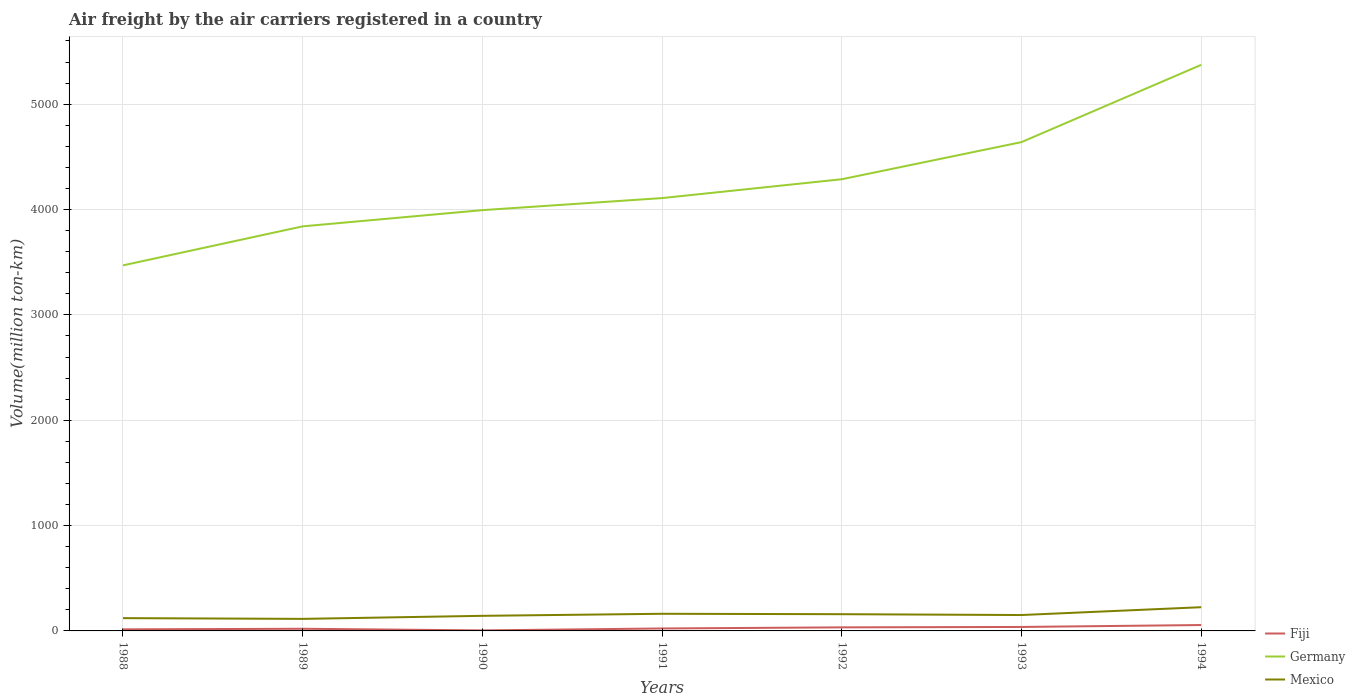How many different coloured lines are there?
Offer a terse response. 3. Across all years, what is the maximum volume of the air carriers in Mexico?
Offer a very short reply. 114.4. In which year was the volume of the air carriers in Mexico maximum?
Your answer should be compact. 1989. What is the total volume of the air carriers in Germany in the graph?
Your answer should be very brief. -1379.1. What is the difference between the highest and the second highest volume of the air carriers in Mexico?
Make the answer very short. 110.8. How many lines are there?
Give a very brief answer. 3. How many years are there in the graph?
Provide a succinct answer. 7. Does the graph contain any zero values?
Your response must be concise. No. Where does the legend appear in the graph?
Provide a short and direct response. Bottom right. How are the legend labels stacked?
Your response must be concise. Vertical. What is the title of the graph?
Your response must be concise. Air freight by the air carriers registered in a country. What is the label or title of the X-axis?
Ensure brevity in your answer.  Years. What is the label or title of the Y-axis?
Your answer should be very brief. Volume(million ton-km). What is the Volume(million ton-km) in Fiji in 1988?
Your response must be concise. 15. What is the Volume(million ton-km) of Germany in 1988?
Provide a succinct answer. 3470. What is the Volume(million ton-km) of Mexico in 1988?
Your answer should be very brief. 121.5. What is the Volume(million ton-km) in Fiji in 1989?
Give a very brief answer. 20.4. What is the Volume(million ton-km) in Germany in 1989?
Make the answer very short. 3840.3. What is the Volume(million ton-km) in Mexico in 1989?
Provide a succinct answer. 114.4. What is the Volume(million ton-km) of Fiji in 1990?
Keep it short and to the point. 5.1. What is the Volume(million ton-km) of Germany in 1990?
Your answer should be compact. 3994.2. What is the Volume(million ton-km) in Mexico in 1990?
Offer a terse response. 143.2. What is the Volume(million ton-km) in Fiji in 1991?
Give a very brief answer. 23.3. What is the Volume(million ton-km) of Germany in 1991?
Offer a terse response. 4108.7. What is the Volume(million ton-km) of Mexico in 1991?
Offer a terse response. 162.7. What is the Volume(million ton-km) of Fiji in 1992?
Your answer should be very brief. 33.8. What is the Volume(million ton-km) in Germany in 1992?
Your response must be concise. 4287.5. What is the Volume(million ton-km) in Mexico in 1992?
Provide a short and direct response. 158.8. What is the Volume(million ton-km) of Fiji in 1993?
Provide a succinct answer. 37.7. What is the Volume(million ton-km) of Germany in 1993?
Give a very brief answer. 4639.9. What is the Volume(million ton-km) of Mexico in 1993?
Make the answer very short. 150.9. What is the Volume(million ton-km) of Fiji in 1994?
Keep it short and to the point. 55.9. What is the Volume(million ton-km) in Germany in 1994?
Your answer should be compact. 5373.3. What is the Volume(million ton-km) in Mexico in 1994?
Give a very brief answer. 225.2. Across all years, what is the maximum Volume(million ton-km) in Fiji?
Ensure brevity in your answer.  55.9. Across all years, what is the maximum Volume(million ton-km) of Germany?
Your answer should be very brief. 5373.3. Across all years, what is the maximum Volume(million ton-km) of Mexico?
Offer a very short reply. 225.2. Across all years, what is the minimum Volume(million ton-km) in Fiji?
Offer a very short reply. 5.1. Across all years, what is the minimum Volume(million ton-km) in Germany?
Offer a very short reply. 3470. Across all years, what is the minimum Volume(million ton-km) of Mexico?
Offer a very short reply. 114.4. What is the total Volume(million ton-km) in Fiji in the graph?
Ensure brevity in your answer.  191.2. What is the total Volume(million ton-km) of Germany in the graph?
Offer a terse response. 2.97e+04. What is the total Volume(million ton-km) of Mexico in the graph?
Give a very brief answer. 1076.7. What is the difference between the Volume(million ton-km) in Fiji in 1988 and that in 1989?
Offer a terse response. -5.4. What is the difference between the Volume(million ton-km) of Germany in 1988 and that in 1989?
Offer a terse response. -370.3. What is the difference between the Volume(million ton-km) of Mexico in 1988 and that in 1989?
Keep it short and to the point. 7.1. What is the difference between the Volume(million ton-km) in Fiji in 1988 and that in 1990?
Offer a terse response. 9.9. What is the difference between the Volume(million ton-km) in Germany in 1988 and that in 1990?
Give a very brief answer. -524.2. What is the difference between the Volume(million ton-km) in Mexico in 1988 and that in 1990?
Ensure brevity in your answer.  -21.7. What is the difference between the Volume(million ton-km) in Germany in 1988 and that in 1991?
Provide a succinct answer. -638.7. What is the difference between the Volume(million ton-km) of Mexico in 1988 and that in 1991?
Offer a very short reply. -41.2. What is the difference between the Volume(million ton-km) of Fiji in 1988 and that in 1992?
Offer a terse response. -18.8. What is the difference between the Volume(million ton-km) of Germany in 1988 and that in 1992?
Provide a succinct answer. -817.5. What is the difference between the Volume(million ton-km) of Mexico in 1988 and that in 1992?
Provide a succinct answer. -37.3. What is the difference between the Volume(million ton-km) of Fiji in 1988 and that in 1993?
Provide a succinct answer. -22.7. What is the difference between the Volume(million ton-km) of Germany in 1988 and that in 1993?
Your answer should be very brief. -1169.9. What is the difference between the Volume(million ton-km) in Mexico in 1988 and that in 1993?
Provide a succinct answer. -29.4. What is the difference between the Volume(million ton-km) in Fiji in 1988 and that in 1994?
Provide a succinct answer. -40.9. What is the difference between the Volume(million ton-km) of Germany in 1988 and that in 1994?
Your answer should be compact. -1903.3. What is the difference between the Volume(million ton-km) of Mexico in 1988 and that in 1994?
Your answer should be very brief. -103.7. What is the difference between the Volume(million ton-km) of Fiji in 1989 and that in 1990?
Provide a short and direct response. 15.3. What is the difference between the Volume(million ton-km) of Germany in 1989 and that in 1990?
Ensure brevity in your answer.  -153.9. What is the difference between the Volume(million ton-km) of Mexico in 1989 and that in 1990?
Make the answer very short. -28.8. What is the difference between the Volume(million ton-km) in Germany in 1989 and that in 1991?
Offer a very short reply. -268.4. What is the difference between the Volume(million ton-km) of Mexico in 1989 and that in 1991?
Offer a very short reply. -48.3. What is the difference between the Volume(million ton-km) in Fiji in 1989 and that in 1992?
Provide a succinct answer. -13.4. What is the difference between the Volume(million ton-km) of Germany in 1989 and that in 1992?
Your answer should be very brief. -447.2. What is the difference between the Volume(million ton-km) in Mexico in 1989 and that in 1992?
Provide a succinct answer. -44.4. What is the difference between the Volume(million ton-km) of Fiji in 1989 and that in 1993?
Offer a terse response. -17.3. What is the difference between the Volume(million ton-km) of Germany in 1989 and that in 1993?
Your answer should be very brief. -799.6. What is the difference between the Volume(million ton-km) in Mexico in 1989 and that in 1993?
Your response must be concise. -36.5. What is the difference between the Volume(million ton-km) in Fiji in 1989 and that in 1994?
Keep it short and to the point. -35.5. What is the difference between the Volume(million ton-km) of Germany in 1989 and that in 1994?
Your answer should be compact. -1533. What is the difference between the Volume(million ton-km) of Mexico in 1989 and that in 1994?
Offer a very short reply. -110.8. What is the difference between the Volume(million ton-km) of Fiji in 1990 and that in 1991?
Offer a very short reply. -18.2. What is the difference between the Volume(million ton-km) of Germany in 1990 and that in 1991?
Keep it short and to the point. -114.5. What is the difference between the Volume(million ton-km) in Mexico in 1990 and that in 1991?
Offer a very short reply. -19.5. What is the difference between the Volume(million ton-km) of Fiji in 1990 and that in 1992?
Offer a very short reply. -28.7. What is the difference between the Volume(million ton-km) of Germany in 1990 and that in 1992?
Offer a very short reply. -293.3. What is the difference between the Volume(million ton-km) in Mexico in 1990 and that in 1992?
Offer a very short reply. -15.6. What is the difference between the Volume(million ton-km) in Fiji in 1990 and that in 1993?
Offer a terse response. -32.6. What is the difference between the Volume(million ton-km) of Germany in 1990 and that in 1993?
Keep it short and to the point. -645.7. What is the difference between the Volume(million ton-km) of Mexico in 1990 and that in 1993?
Provide a succinct answer. -7.7. What is the difference between the Volume(million ton-km) in Fiji in 1990 and that in 1994?
Your response must be concise. -50.8. What is the difference between the Volume(million ton-km) of Germany in 1990 and that in 1994?
Offer a terse response. -1379.1. What is the difference between the Volume(million ton-km) in Mexico in 1990 and that in 1994?
Offer a very short reply. -82. What is the difference between the Volume(million ton-km) of Fiji in 1991 and that in 1992?
Offer a terse response. -10.5. What is the difference between the Volume(million ton-km) of Germany in 1991 and that in 1992?
Your answer should be compact. -178.8. What is the difference between the Volume(million ton-km) in Fiji in 1991 and that in 1993?
Provide a succinct answer. -14.4. What is the difference between the Volume(million ton-km) in Germany in 1991 and that in 1993?
Give a very brief answer. -531.2. What is the difference between the Volume(million ton-km) in Mexico in 1991 and that in 1993?
Make the answer very short. 11.8. What is the difference between the Volume(million ton-km) in Fiji in 1991 and that in 1994?
Your response must be concise. -32.6. What is the difference between the Volume(million ton-km) of Germany in 1991 and that in 1994?
Your answer should be compact. -1264.6. What is the difference between the Volume(million ton-km) in Mexico in 1991 and that in 1994?
Keep it short and to the point. -62.5. What is the difference between the Volume(million ton-km) of Fiji in 1992 and that in 1993?
Offer a very short reply. -3.9. What is the difference between the Volume(million ton-km) in Germany in 1992 and that in 1993?
Offer a terse response. -352.4. What is the difference between the Volume(million ton-km) of Mexico in 1992 and that in 1993?
Keep it short and to the point. 7.9. What is the difference between the Volume(million ton-km) of Fiji in 1992 and that in 1994?
Your response must be concise. -22.1. What is the difference between the Volume(million ton-km) of Germany in 1992 and that in 1994?
Ensure brevity in your answer.  -1085.8. What is the difference between the Volume(million ton-km) in Mexico in 1992 and that in 1994?
Ensure brevity in your answer.  -66.4. What is the difference between the Volume(million ton-km) in Fiji in 1993 and that in 1994?
Provide a succinct answer. -18.2. What is the difference between the Volume(million ton-km) in Germany in 1993 and that in 1994?
Offer a terse response. -733.4. What is the difference between the Volume(million ton-km) of Mexico in 1993 and that in 1994?
Offer a terse response. -74.3. What is the difference between the Volume(million ton-km) of Fiji in 1988 and the Volume(million ton-km) of Germany in 1989?
Your answer should be compact. -3825.3. What is the difference between the Volume(million ton-km) of Fiji in 1988 and the Volume(million ton-km) of Mexico in 1989?
Provide a short and direct response. -99.4. What is the difference between the Volume(million ton-km) in Germany in 1988 and the Volume(million ton-km) in Mexico in 1989?
Provide a short and direct response. 3355.6. What is the difference between the Volume(million ton-km) in Fiji in 1988 and the Volume(million ton-km) in Germany in 1990?
Your response must be concise. -3979.2. What is the difference between the Volume(million ton-km) in Fiji in 1988 and the Volume(million ton-km) in Mexico in 1990?
Ensure brevity in your answer.  -128.2. What is the difference between the Volume(million ton-km) in Germany in 1988 and the Volume(million ton-km) in Mexico in 1990?
Your response must be concise. 3326.8. What is the difference between the Volume(million ton-km) of Fiji in 1988 and the Volume(million ton-km) of Germany in 1991?
Provide a short and direct response. -4093.7. What is the difference between the Volume(million ton-km) of Fiji in 1988 and the Volume(million ton-km) of Mexico in 1991?
Your response must be concise. -147.7. What is the difference between the Volume(million ton-km) in Germany in 1988 and the Volume(million ton-km) in Mexico in 1991?
Give a very brief answer. 3307.3. What is the difference between the Volume(million ton-km) in Fiji in 1988 and the Volume(million ton-km) in Germany in 1992?
Keep it short and to the point. -4272.5. What is the difference between the Volume(million ton-km) in Fiji in 1988 and the Volume(million ton-km) in Mexico in 1992?
Keep it short and to the point. -143.8. What is the difference between the Volume(million ton-km) in Germany in 1988 and the Volume(million ton-km) in Mexico in 1992?
Your answer should be very brief. 3311.2. What is the difference between the Volume(million ton-km) of Fiji in 1988 and the Volume(million ton-km) of Germany in 1993?
Provide a short and direct response. -4624.9. What is the difference between the Volume(million ton-km) in Fiji in 1988 and the Volume(million ton-km) in Mexico in 1993?
Your answer should be compact. -135.9. What is the difference between the Volume(million ton-km) of Germany in 1988 and the Volume(million ton-km) of Mexico in 1993?
Keep it short and to the point. 3319.1. What is the difference between the Volume(million ton-km) in Fiji in 1988 and the Volume(million ton-km) in Germany in 1994?
Provide a succinct answer. -5358.3. What is the difference between the Volume(million ton-km) of Fiji in 1988 and the Volume(million ton-km) of Mexico in 1994?
Your answer should be compact. -210.2. What is the difference between the Volume(million ton-km) in Germany in 1988 and the Volume(million ton-km) in Mexico in 1994?
Your answer should be very brief. 3244.8. What is the difference between the Volume(million ton-km) of Fiji in 1989 and the Volume(million ton-km) of Germany in 1990?
Your response must be concise. -3973.8. What is the difference between the Volume(million ton-km) in Fiji in 1989 and the Volume(million ton-km) in Mexico in 1990?
Offer a very short reply. -122.8. What is the difference between the Volume(million ton-km) of Germany in 1989 and the Volume(million ton-km) of Mexico in 1990?
Provide a short and direct response. 3697.1. What is the difference between the Volume(million ton-km) in Fiji in 1989 and the Volume(million ton-km) in Germany in 1991?
Your answer should be very brief. -4088.3. What is the difference between the Volume(million ton-km) in Fiji in 1989 and the Volume(million ton-km) in Mexico in 1991?
Offer a terse response. -142.3. What is the difference between the Volume(million ton-km) in Germany in 1989 and the Volume(million ton-km) in Mexico in 1991?
Ensure brevity in your answer.  3677.6. What is the difference between the Volume(million ton-km) in Fiji in 1989 and the Volume(million ton-km) in Germany in 1992?
Offer a terse response. -4267.1. What is the difference between the Volume(million ton-km) in Fiji in 1989 and the Volume(million ton-km) in Mexico in 1992?
Your answer should be compact. -138.4. What is the difference between the Volume(million ton-km) in Germany in 1989 and the Volume(million ton-km) in Mexico in 1992?
Offer a terse response. 3681.5. What is the difference between the Volume(million ton-km) in Fiji in 1989 and the Volume(million ton-km) in Germany in 1993?
Ensure brevity in your answer.  -4619.5. What is the difference between the Volume(million ton-km) of Fiji in 1989 and the Volume(million ton-km) of Mexico in 1993?
Provide a short and direct response. -130.5. What is the difference between the Volume(million ton-km) of Germany in 1989 and the Volume(million ton-km) of Mexico in 1993?
Provide a short and direct response. 3689.4. What is the difference between the Volume(million ton-km) of Fiji in 1989 and the Volume(million ton-km) of Germany in 1994?
Keep it short and to the point. -5352.9. What is the difference between the Volume(million ton-km) of Fiji in 1989 and the Volume(million ton-km) of Mexico in 1994?
Your response must be concise. -204.8. What is the difference between the Volume(million ton-km) in Germany in 1989 and the Volume(million ton-km) in Mexico in 1994?
Make the answer very short. 3615.1. What is the difference between the Volume(million ton-km) of Fiji in 1990 and the Volume(million ton-km) of Germany in 1991?
Your answer should be compact. -4103.6. What is the difference between the Volume(million ton-km) of Fiji in 1990 and the Volume(million ton-km) of Mexico in 1991?
Keep it short and to the point. -157.6. What is the difference between the Volume(million ton-km) of Germany in 1990 and the Volume(million ton-km) of Mexico in 1991?
Give a very brief answer. 3831.5. What is the difference between the Volume(million ton-km) of Fiji in 1990 and the Volume(million ton-km) of Germany in 1992?
Offer a terse response. -4282.4. What is the difference between the Volume(million ton-km) in Fiji in 1990 and the Volume(million ton-km) in Mexico in 1992?
Your response must be concise. -153.7. What is the difference between the Volume(million ton-km) of Germany in 1990 and the Volume(million ton-km) of Mexico in 1992?
Your answer should be compact. 3835.4. What is the difference between the Volume(million ton-km) of Fiji in 1990 and the Volume(million ton-km) of Germany in 1993?
Provide a succinct answer. -4634.8. What is the difference between the Volume(million ton-km) in Fiji in 1990 and the Volume(million ton-km) in Mexico in 1993?
Give a very brief answer. -145.8. What is the difference between the Volume(million ton-km) of Germany in 1990 and the Volume(million ton-km) of Mexico in 1993?
Provide a short and direct response. 3843.3. What is the difference between the Volume(million ton-km) of Fiji in 1990 and the Volume(million ton-km) of Germany in 1994?
Provide a short and direct response. -5368.2. What is the difference between the Volume(million ton-km) in Fiji in 1990 and the Volume(million ton-km) in Mexico in 1994?
Your answer should be compact. -220.1. What is the difference between the Volume(million ton-km) of Germany in 1990 and the Volume(million ton-km) of Mexico in 1994?
Provide a succinct answer. 3769. What is the difference between the Volume(million ton-km) in Fiji in 1991 and the Volume(million ton-km) in Germany in 1992?
Give a very brief answer. -4264.2. What is the difference between the Volume(million ton-km) in Fiji in 1991 and the Volume(million ton-km) in Mexico in 1992?
Make the answer very short. -135.5. What is the difference between the Volume(million ton-km) in Germany in 1991 and the Volume(million ton-km) in Mexico in 1992?
Offer a very short reply. 3949.9. What is the difference between the Volume(million ton-km) of Fiji in 1991 and the Volume(million ton-km) of Germany in 1993?
Provide a succinct answer. -4616.6. What is the difference between the Volume(million ton-km) of Fiji in 1991 and the Volume(million ton-km) of Mexico in 1993?
Make the answer very short. -127.6. What is the difference between the Volume(million ton-km) in Germany in 1991 and the Volume(million ton-km) in Mexico in 1993?
Your answer should be compact. 3957.8. What is the difference between the Volume(million ton-km) of Fiji in 1991 and the Volume(million ton-km) of Germany in 1994?
Provide a succinct answer. -5350. What is the difference between the Volume(million ton-km) of Fiji in 1991 and the Volume(million ton-km) of Mexico in 1994?
Give a very brief answer. -201.9. What is the difference between the Volume(million ton-km) in Germany in 1991 and the Volume(million ton-km) in Mexico in 1994?
Offer a terse response. 3883.5. What is the difference between the Volume(million ton-km) of Fiji in 1992 and the Volume(million ton-km) of Germany in 1993?
Your response must be concise. -4606.1. What is the difference between the Volume(million ton-km) in Fiji in 1992 and the Volume(million ton-km) in Mexico in 1993?
Provide a short and direct response. -117.1. What is the difference between the Volume(million ton-km) in Germany in 1992 and the Volume(million ton-km) in Mexico in 1993?
Make the answer very short. 4136.6. What is the difference between the Volume(million ton-km) in Fiji in 1992 and the Volume(million ton-km) in Germany in 1994?
Your answer should be compact. -5339.5. What is the difference between the Volume(million ton-km) in Fiji in 1992 and the Volume(million ton-km) in Mexico in 1994?
Give a very brief answer. -191.4. What is the difference between the Volume(million ton-km) of Germany in 1992 and the Volume(million ton-km) of Mexico in 1994?
Your answer should be very brief. 4062.3. What is the difference between the Volume(million ton-km) in Fiji in 1993 and the Volume(million ton-km) in Germany in 1994?
Keep it short and to the point. -5335.6. What is the difference between the Volume(million ton-km) in Fiji in 1993 and the Volume(million ton-km) in Mexico in 1994?
Make the answer very short. -187.5. What is the difference between the Volume(million ton-km) in Germany in 1993 and the Volume(million ton-km) in Mexico in 1994?
Your answer should be very brief. 4414.7. What is the average Volume(million ton-km) of Fiji per year?
Keep it short and to the point. 27.31. What is the average Volume(million ton-km) in Germany per year?
Keep it short and to the point. 4244.84. What is the average Volume(million ton-km) in Mexico per year?
Provide a succinct answer. 153.81. In the year 1988, what is the difference between the Volume(million ton-km) of Fiji and Volume(million ton-km) of Germany?
Your response must be concise. -3455. In the year 1988, what is the difference between the Volume(million ton-km) of Fiji and Volume(million ton-km) of Mexico?
Give a very brief answer. -106.5. In the year 1988, what is the difference between the Volume(million ton-km) in Germany and Volume(million ton-km) in Mexico?
Make the answer very short. 3348.5. In the year 1989, what is the difference between the Volume(million ton-km) of Fiji and Volume(million ton-km) of Germany?
Make the answer very short. -3819.9. In the year 1989, what is the difference between the Volume(million ton-km) of Fiji and Volume(million ton-km) of Mexico?
Your answer should be compact. -94. In the year 1989, what is the difference between the Volume(million ton-km) of Germany and Volume(million ton-km) of Mexico?
Give a very brief answer. 3725.9. In the year 1990, what is the difference between the Volume(million ton-km) of Fiji and Volume(million ton-km) of Germany?
Provide a succinct answer. -3989.1. In the year 1990, what is the difference between the Volume(million ton-km) in Fiji and Volume(million ton-km) in Mexico?
Your answer should be very brief. -138.1. In the year 1990, what is the difference between the Volume(million ton-km) in Germany and Volume(million ton-km) in Mexico?
Offer a very short reply. 3851. In the year 1991, what is the difference between the Volume(million ton-km) in Fiji and Volume(million ton-km) in Germany?
Ensure brevity in your answer.  -4085.4. In the year 1991, what is the difference between the Volume(million ton-km) of Fiji and Volume(million ton-km) of Mexico?
Make the answer very short. -139.4. In the year 1991, what is the difference between the Volume(million ton-km) in Germany and Volume(million ton-km) in Mexico?
Offer a very short reply. 3946. In the year 1992, what is the difference between the Volume(million ton-km) in Fiji and Volume(million ton-km) in Germany?
Your response must be concise. -4253.7. In the year 1992, what is the difference between the Volume(million ton-km) in Fiji and Volume(million ton-km) in Mexico?
Your answer should be very brief. -125. In the year 1992, what is the difference between the Volume(million ton-km) in Germany and Volume(million ton-km) in Mexico?
Provide a short and direct response. 4128.7. In the year 1993, what is the difference between the Volume(million ton-km) of Fiji and Volume(million ton-km) of Germany?
Your answer should be compact. -4602.2. In the year 1993, what is the difference between the Volume(million ton-km) in Fiji and Volume(million ton-km) in Mexico?
Your response must be concise. -113.2. In the year 1993, what is the difference between the Volume(million ton-km) of Germany and Volume(million ton-km) of Mexico?
Your answer should be compact. 4489. In the year 1994, what is the difference between the Volume(million ton-km) in Fiji and Volume(million ton-km) in Germany?
Your answer should be compact. -5317.4. In the year 1994, what is the difference between the Volume(million ton-km) of Fiji and Volume(million ton-km) of Mexico?
Make the answer very short. -169.3. In the year 1994, what is the difference between the Volume(million ton-km) of Germany and Volume(million ton-km) of Mexico?
Your response must be concise. 5148.1. What is the ratio of the Volume(million ton-km) in Fiji in 1988 to that in 1989?
Provide a short and direct response. 0.74. What is the ratio of the Volume(million ton-km) in Germany in 1988 to that in 1989?
Provide a short and direct response. 0.9. What is the ratio of the Volume(million ton-km) in Mexico in 1988 to that in 1989?
Provide a succinct answer. 1.06. What is the ratio of the Volume(million ton-km) of Fiji in 1988 to that in 1990?
Ensure brevity in your answer.  2.94. What is the ratio of the Volume(million ton-km) in Germany in 1988 to that in 1990?
Your answer should be very brief. 0.87. What is the ratio of the Volume(million ton-km) in Mexico in 1988 to that in 1990?
Make the answer very short. 0.85. What is the ratio of the Volume(million ton-km) of Fiji in 1988 to that in 1991?
Provide a short and direct response. 0.64. What is the ratio of the Volume(million ton-km) of Germany in 1988 to that in 1991?
Ensure brevity in your answer.  0.84. What is the ratio of the Volume(million ton-km) in Mexico in 1988 to that in 1991?
Ensure brevity in your answer.  0.75. What is the ratio of the Volume(million ton-km) in Fiji in 1988 to that in 1992?
Provide a short and direct response. 0.44. What is the ratio of the Volume(million ton-km) in Germany in 1988 to that in 1992?
Offer a very short reply. 0.81. What is the ratio of the Volume(million ton-km) in Mexico in 1988 to that in 1992?
Give a very brief answer. 0.77. What is the ratio of the Volume(million ton-km) in Fiji in 1988 to that in 1993?
Keep it short and to the point. 0.4. What is the ratio of the Volume(million ton-km) in Germany in 1988 to that in 1993?
Your answer should be compact. 0.75. What is the ratio of the Volume(million ton-km) in Mexico in 1988 to that in 1993?
Give a very brief answer. 0.81. What is the ratio of the Volume(million ton-km) in Fiji in 1988 to that in 1994?
Your answer should be very brief. 0.27. What is the ratio of the Volume(million ton-km) in Germany in 1988 to that in 1994?
Keep it short and to the point. 0.65. What is the ratio of the Volume(million ton-km) in Mexico in 1988 to that in 1994?
Offer a terse response. 0.54. What is the ratio of the Volume(million ton-km) of Germany in 1989 to that in 1990?
Offer a very short reply. 0.96. What is the ratio of the Volume(million ton-km) in Mexico in 1989 to that in 1990?
Your answer should be very brief. 0.8. What is the ratio of the Volume(million ton-km) in Fiji in 1989 to that in 1991?
Provide a succinct answer. 0.88. What is the ratio of the Volume(million ton-km) in Germany in 1989 to that in 1991?
Offer a terse response. 0.93. What is the ratio of the Volume(million ton-km) in Mexico in 1989 to that in 1991?
Give a very brief answer. 0.7. What is the ratio of the Volume(million ton-km) in Fiji in 1989 to that in 1992?
Your response must be concise. 0.6. What is the ratio of the Volume(million ton-km) in Germany in 1989 to that in 1992?
Your answer should be compact. 0.9. What is the ratio of the Volume(million ton-km) of Mexico in 1989 to that in 1992?
Your answer should be compact. 0.72. What is the ratio of the Volume(million ton-km) in Fiji in 1989 to that in 1993?
Offer a very short reply. 0.54. What is the ratio of the Volume(million ton-km) in Germany in 1989 to that in 1993?
Offer a terse response. 0.83. What is the ratio of the Volume(million ton-km) in Mexico in 1989 to that in 1993?
Provide a short and direct response. 0.76. What is the ratio of the Volume(million ton-km) of Fiji in 1989 to that in 1994?
Provide a short and direct response. 0.36. What is the ratio of the Volume(million ton-km) in Germany in 1989 to that in 1994?
Offer a very short reply. 0.71. What is the ratio of the Volume(million ton-km) in Mexico in 1989 to that in 1994?
Your answer should be very brief. 0.51. What is the ratio of the Volume(million ton-km) of Fiji in 1990 to that in 1991?
Your answer should be compact. 0.22. What is the ratio of the Volume(million ton-km) of Germany in 1990 to that in 1991?
Provide a short and direct response. 0.97. What is the ratio of the Volume(million ton-km) in Mexico in 1990 to that in 1991?
Your answer should be very brief. 0.88. What is the ratio of the Volume(million ton-km) in Fiji in 1990 to that in 1992?
Make the answer very short. 0.15. What is the ratio of the Volume(million ton-km) of Germany in 1990 to that in 1992?
Your response must be concise. 0.93. What is the ratio of the Volume(million ton-km) in Mexico in 1990 to that in 1992?
Offer a terse response. 0.9. What is the ratio of the Volume(million ton-km) of Fiji in 1990 to that in 1993?
Provide a succinct answer. 0.14. What is the ratio of the Volume(million ton-km) of Germany in 1990 to that in 1993?
Provide a short and direct response. 0.86. What is the ratio of the Volume(million ton-km) in Mexico in 1990 to that in 1993?
Your answer should be compact. 0.95. What is the ratio of the Volume(million ton-km) of Fiji in 1990 to that in 1994?
Make the answer very short. 0.09. What is the ratio of the Volume(million ton-km) of Germany in 1990 to that in 1994?
Offer a terse response. 0.74. What is the ratio of the Volume(million ton-km) in Mexico in 1990 to that in 1994?
Provide a short and direct response. 0.64. What is the ratio of the Volume(million ton-km) of Fiji in 1991 to that in 1992?
Your answer should be very brief. 0.69. What is the ratio of the Volume(million ton-km) of Mexico in 1991 to that in 1992?
Your response must be concise. 1.02. What is the ratio of the Volume(million ton-km) of Fiji in 1991 to that in 1993?
Provide a succinct answer. 0.62. What is the ratio of the Volume(million ton-km) in Germany in 1991 to that in 1993?
Give a very brief answer. 0.89. What is the ratio of the Volume(million ton-km) in Mexico in 1991 to that in 1993?
Ensure brevity in your answer.  1.08. What is the ratio of the Volume(million ton-km) in Fiji in 1991 to that in 1994?
Your answer should be compact. 0.42. What is the ratio of the Volume(million ton-km) of Germany in 1991 to that in 1994?
Your response must be concise. 0.76. What is the ratio of the Volume(million ton-km) of Mexico in 1991 to that in 1994?
Make the answer very short. 0.72. What is the ratio of the Volume(million ton-km) of Fiji in 1992 to that in 1993?
Your response must be concise. 0.9. What is the ratio of the Volume(million ton-km) in Germany in 1992 to that in 1993?
Your answer should be compact. 0.92. What is the ratio of the Volume(million ton-km) in Mexico in 1992 to that in 1993?
Keep it short and to the point. 1.05. What is the ratio of the Volume(million ton-km) in Fiji in 1992 to that in 1994?
Give a very brief answer. 0.6. What is the ratio of the Volume(million ton-km) of Germany in 1992 to that in 1994?
Keep it short and to the point. 0.8. What is the ratio of the Volume(million ton-km) of Mexico in 1992 to that in 1994?
Your answer should be compact. 0.71. What is the ratio of the Volume(million ton-km) in Fiji in 1993 to that in 1994?
Provide a succinct answer. 0.67. What is the ratio of the Volume(million ton-km) in Germany in 1993 to that in 1994?
Offer a terse response. 0.86. What is the ratio of the Volume(million ton-km) of Mexico in 1993 to that in 1994?
Your answer should be compact. 0.67. What is the difference between the highest and the second highest Volume(million ton-km) of Fiji?
Provide a short and direct response. 18.2. What is the difference between the highest and the second highest Volume(million ton-km) of Germany?
Keep it short and to the point. 733.4. What is the difference between the highest and the second highest Volume(million ton-km) of Mexico?
Make the answer very short. 62.5. What is the difference between the highest and the lowest Volume(million ton-km) in Fiji?
Give a very brief answer. 50.8. What is the difference between the highest and the lowest Volume(million ton-km) in Germany?
Offer a terse response. 1903.3. What is the difference between the highest and the lowest Volume(million ton-km) of Mexico?
Your answer should be very brief. 110.8. 